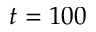<formula> <loc_0><loc_0><loc_500><loc_500>t = 1 0 0</formula> 